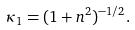Convert formula to latex. <formula><loc_0><loc_0><loc_500><loc_500>\kappa _ { 1 } = ( 1 + n ^ { 2 } ) ^ { - 1 / 2 } .</formula> 